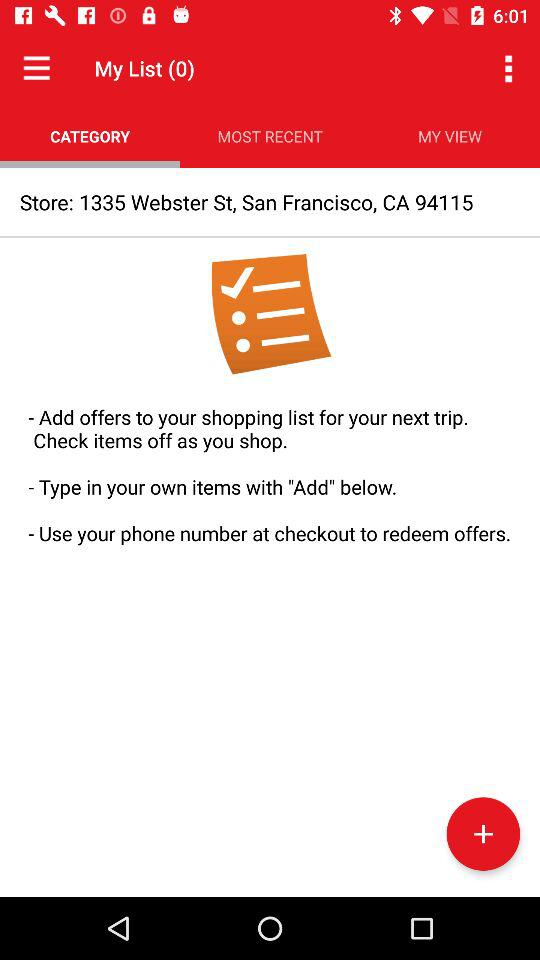What's the store address? The store address is 1335 Webster St., San Francisco, CA 94115. 